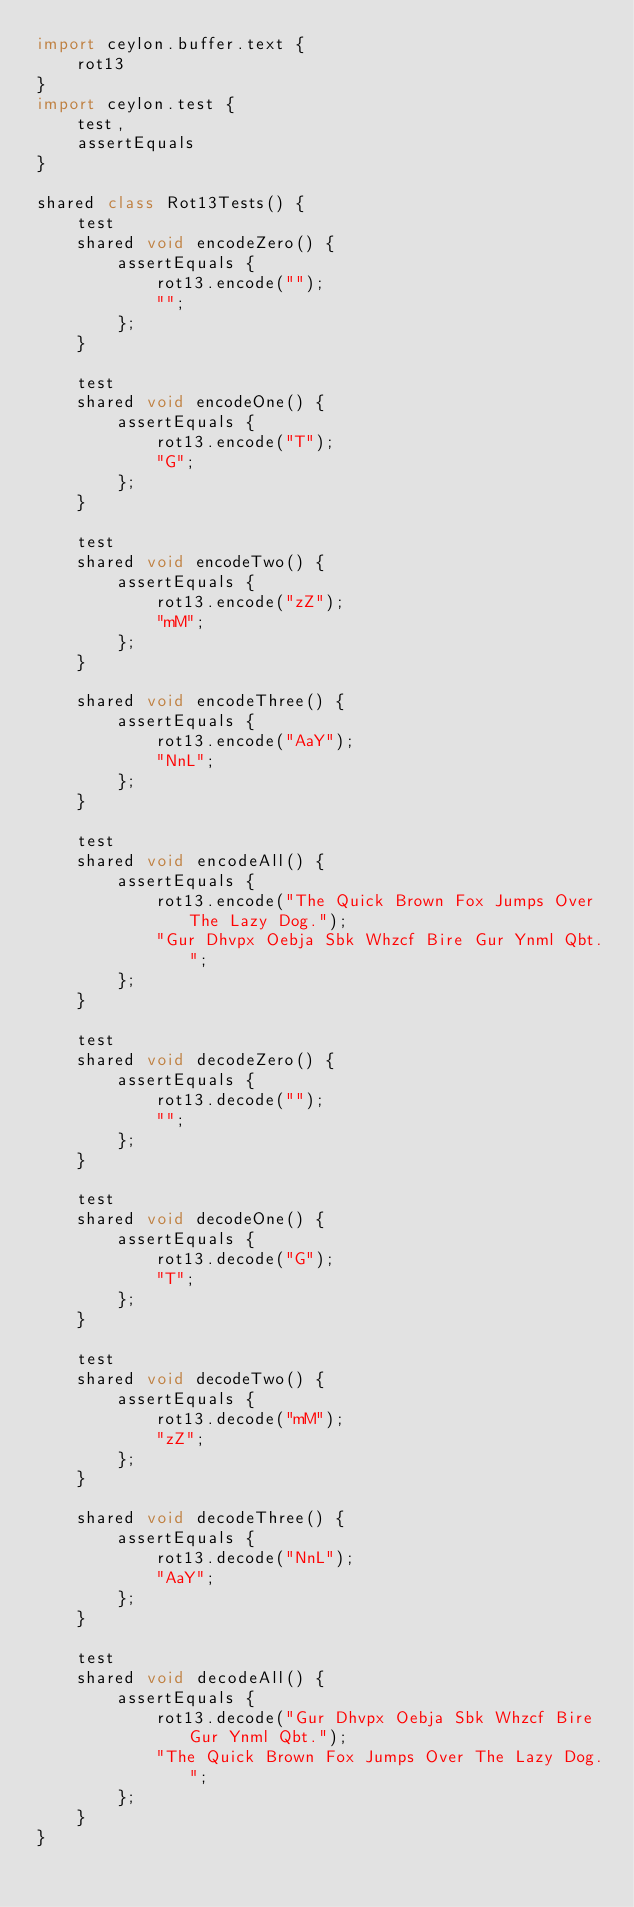<code> <loc_0><loc_0><loc_500><loc_500><_Ceylon_>import ceylon.buffer.text {
    rot13
}
import ceylon.test {
    test,
    assertEquals
}

shared class Rot13Tests() {
    test
    shared void encodeZero() {
        assertEquals {
            rot13.encode("");
            "";
        };
    }
    
    test
    shared void encodeOne() {
        assertEquals {
            rot13.encode("T");
            "G";
        };
    }
    
    test
    shared void encodeTwo() {
        assertEquals {
            rot13.encode("zZ");
            "mM";
        };
    }
    
    shared void encodeThree() {
        assertEquals {
            rot13.encode("AaY");
            "NnL";
        };
    }
    
    test
    shared void encodeAll() {
        assertEquals {
            rot13.encode("The Quick Brown Fox Jumps Over The Lazy Dog.");
            "Gur Dhvpx Oebja Sbk Whzcf Bire Gur Ynml Qbt.";
        };
    }
    
    test
    shared void decodeZero() {
        assertEquals {
            rot13.decode("");
            "";
        };
    }
    
    test
    shared void decodeOne() {
        assertEquals {
            rot13.decode("G");
            "T";
        };
    }
    
    test
    shared void decodeTwo() {
        assertEquals {
            rot13.decode("mM");
            "zZ";
        };
    }
    
    shared void decodeThree() {
        assertEquals {
            rot13.decode("NnL");
            "AaY";
        };
    }
    
    test
    shared void decodeAll() {
        assertEquals {
            rot13.decode("Gur Dhvpx Oebja Sbk Whzcf Bire Gur Ynml Qbt.");
            "The Quick Brown Fox Jumps Over The Lazy Dog.";
        };
    }
}
</code> 